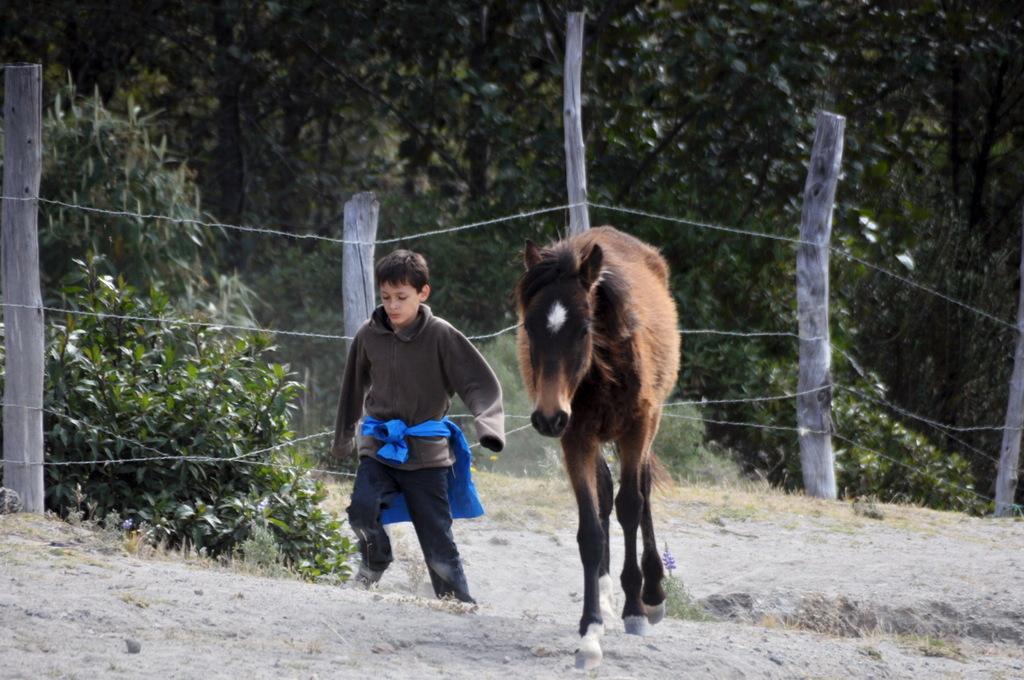Can you describe this image briefly? In this image, we can see a kid beside the horse. There is a fencing in the middle of the image. There are some plants on the left side of the image. In the background, there are some trees. 